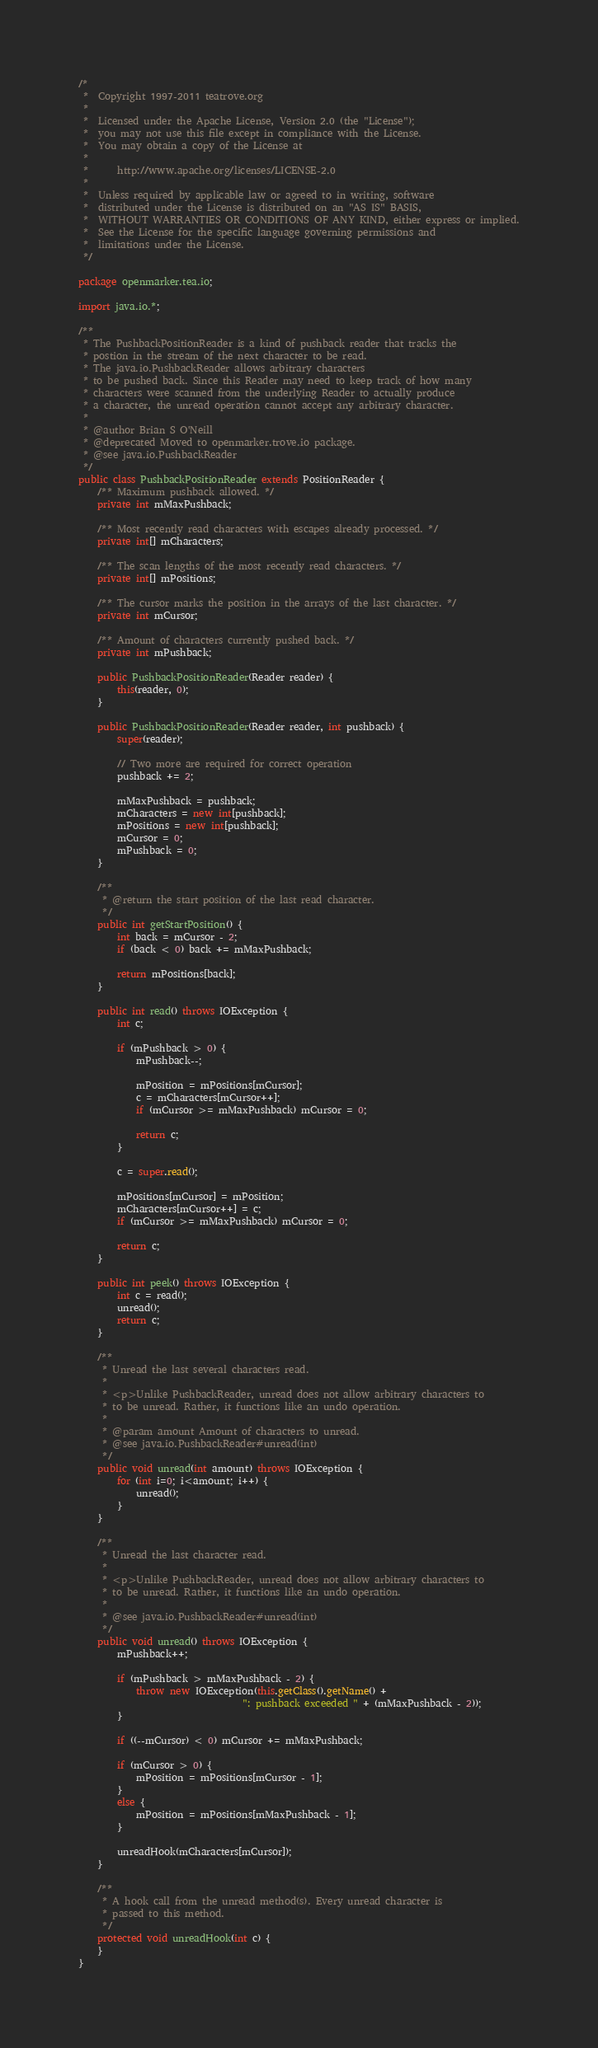<code> <loc_0><loc_0><loc_500><loc_500><_Java_>/*
 *  Copyright 1997-2011 teatrove.org
 *
 *  Licensed under the Apache License, Version 2.0 (the "License");
 *  you may not use this file except in compliance with the License.
 *  You may obtain a copy of the License at
 *
 *      http://www.apache.org/licenses/LICENSE-2.0
 *
 *  Unless required by applicable law or agreed to in writing, software
 *  distributed under the License is distributed on an "AS IS" BASIS,
 *  WITHOUT WARRANTIES OR CONDITIONS OF ANY KIND, either express or implied.
 *  See the License for the specific language governing permissions and
 *  limitations under the License.
 */

package openmarker.tea.io;

import java.io.*;

/**
 * The PushbackPositionReader is a kind of pushback reader that tracks the
 * postion in the stream of the next character to be read.
 * The java.io.PushbackReader allows arbitrary characters
 * to be pushed back. Since this Reader may need to keep track of how many
 * characters were scanned from the underlying Reader to actually produce
 * a character, the unread operation cannot accept any arbitrary character.
 *
 * @author Brian S O'Neill
 * @deprecated Moved to openmarker.trove.io package.
 * @see java.io.PushbackReader
 */
public class PushbackPositionReader extends PositionReader {
    /** Maximum pushback allowed. */
    private int mMaxPushback;

    /** Most recently read characters with escapes already processed. */
    private int[] mCharacters;

    /** The scan lengths of the most recently read characters. */
    private int[] mPositions;

    /** The cursor marks the position in the arrays of the last character. */
    private int mCursor;

    /** Amount of characters currently pushed back. */
    private int mPushback;

    public PushbackPositionReader(Reader reader) {
        this(reader, 0);
    }

    public PushbackPositionReader(Reader reader, int pushback) {
        super(reader);

        // Two more are required for correct operation
        pushback += 2;

        mMaxPushback = pushback;
        mCharacters = new int[pushback];
        mPositions = new int[pushback];
        mCursor = 0;
        mPushback = 0;
    }

    /**
     * @return the start position of the last read character.
     */
    public int getStartPosition() {
        int back = mCursor - 2;
        if (back < 0) back += mMaxPushback;

        return mPositions[back];
    }

    public int read() throws IOException {
        int c;

        if (mPushback > 0) {
            mPushback--;

            mPosition = mPositions[mCursor];
            c = mCharacters[mCursor++];
            if (mCursor >= mMaxPushback) mCursor = 0;

            return c;
        }

        c = super.read();

        mPositions[mCursor] = mPosition;
        mCharacters[mCursor++] = c;
        if (mCursor >= mMaxPushback) mCursor = 0;

        return c;
    }

    public int peek() throws IOException {
        int c = read();
        unread();
        return c;
    }

    /**
     * Unread the last several characters read.
     *
     * <p>Unlike PushbackReader, unread does not allow arbitrary characters to
     * to be unread. Rather, it functions like an undo operation.
     *
     * @param amount Amount of characters to unread.
     * @see java.io.PushbackReader#unread(int)
     */
    public void unread(int amount) throws IOException {
        for (int i=0; i<amount; i++) {
            unread();
        }
    }

    /**
     * Unread the last character read.
     *
     * <p>Unlike PushbackReader, unread does not allow arbitrary characters to
     * to be unread. Rather, it functions like an undo operation.
     *
     * @see java.io.PushbackReader#unread(int)
     */
    public void unread() throws IOException {
        mPushback++;

        if (mPushback > mMaxPushback - 2) {
            throw new IOException(this.getClass().getName() +
                                  ": pushback exceeded " + (mMaxPushback - 2));
        }

        if ((--mCursor) < 0) mCursor += mMaxPushback;

        if (mCursor > 0) {
            mPosition = mPositions[mCursor - 1];
        }
        else {
            mPosition = mPositions[mMaxPushback - 1];
        }

        unreadHook(mCharacters[mCursor]);
    }

    /**
     * A hook call from the unread method(s). Every unread character is
     * passed to this method.
     */
    protected void unreadHook(int c) {
    }
}
</code> 